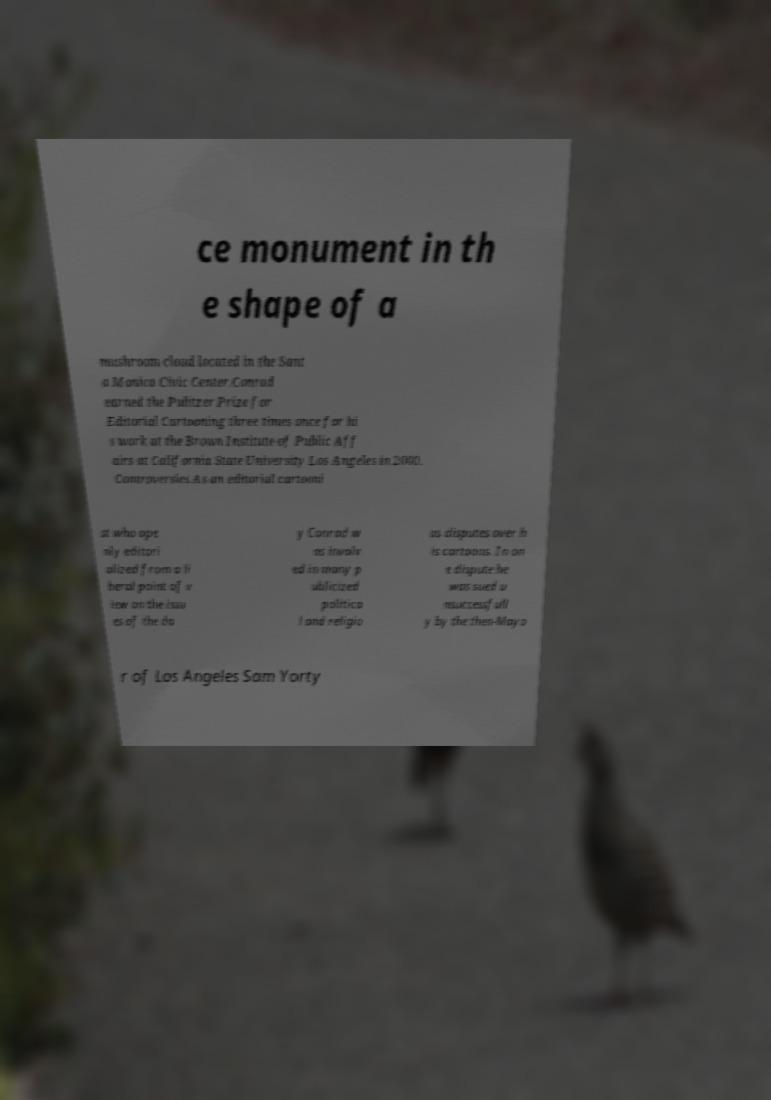Can you read and provide the text displayed in the image?This photo seems to have some interesting text. Can you extract and type it out for me? ce monument in th e shape of a mushroom cloud located in the Sant a Monica Civic Center.Conrad earned the Pulitzer Prize for Editorial Cartooning three times once for hi s work at the Brown Institute of Public Aff airs at California State University Los Angeles in 2000. Controversies.As an editorial cartooni st who ope nly editori alized from a li beral point of v iew on the issu es of the da y Conrad w as involv ed in many p ublicized politica l and religio us disputes over h is cartoons. In on e dispute he was sued u nsuccessfull y by the then-Mayo r of Los Angeles Sam Yorty 